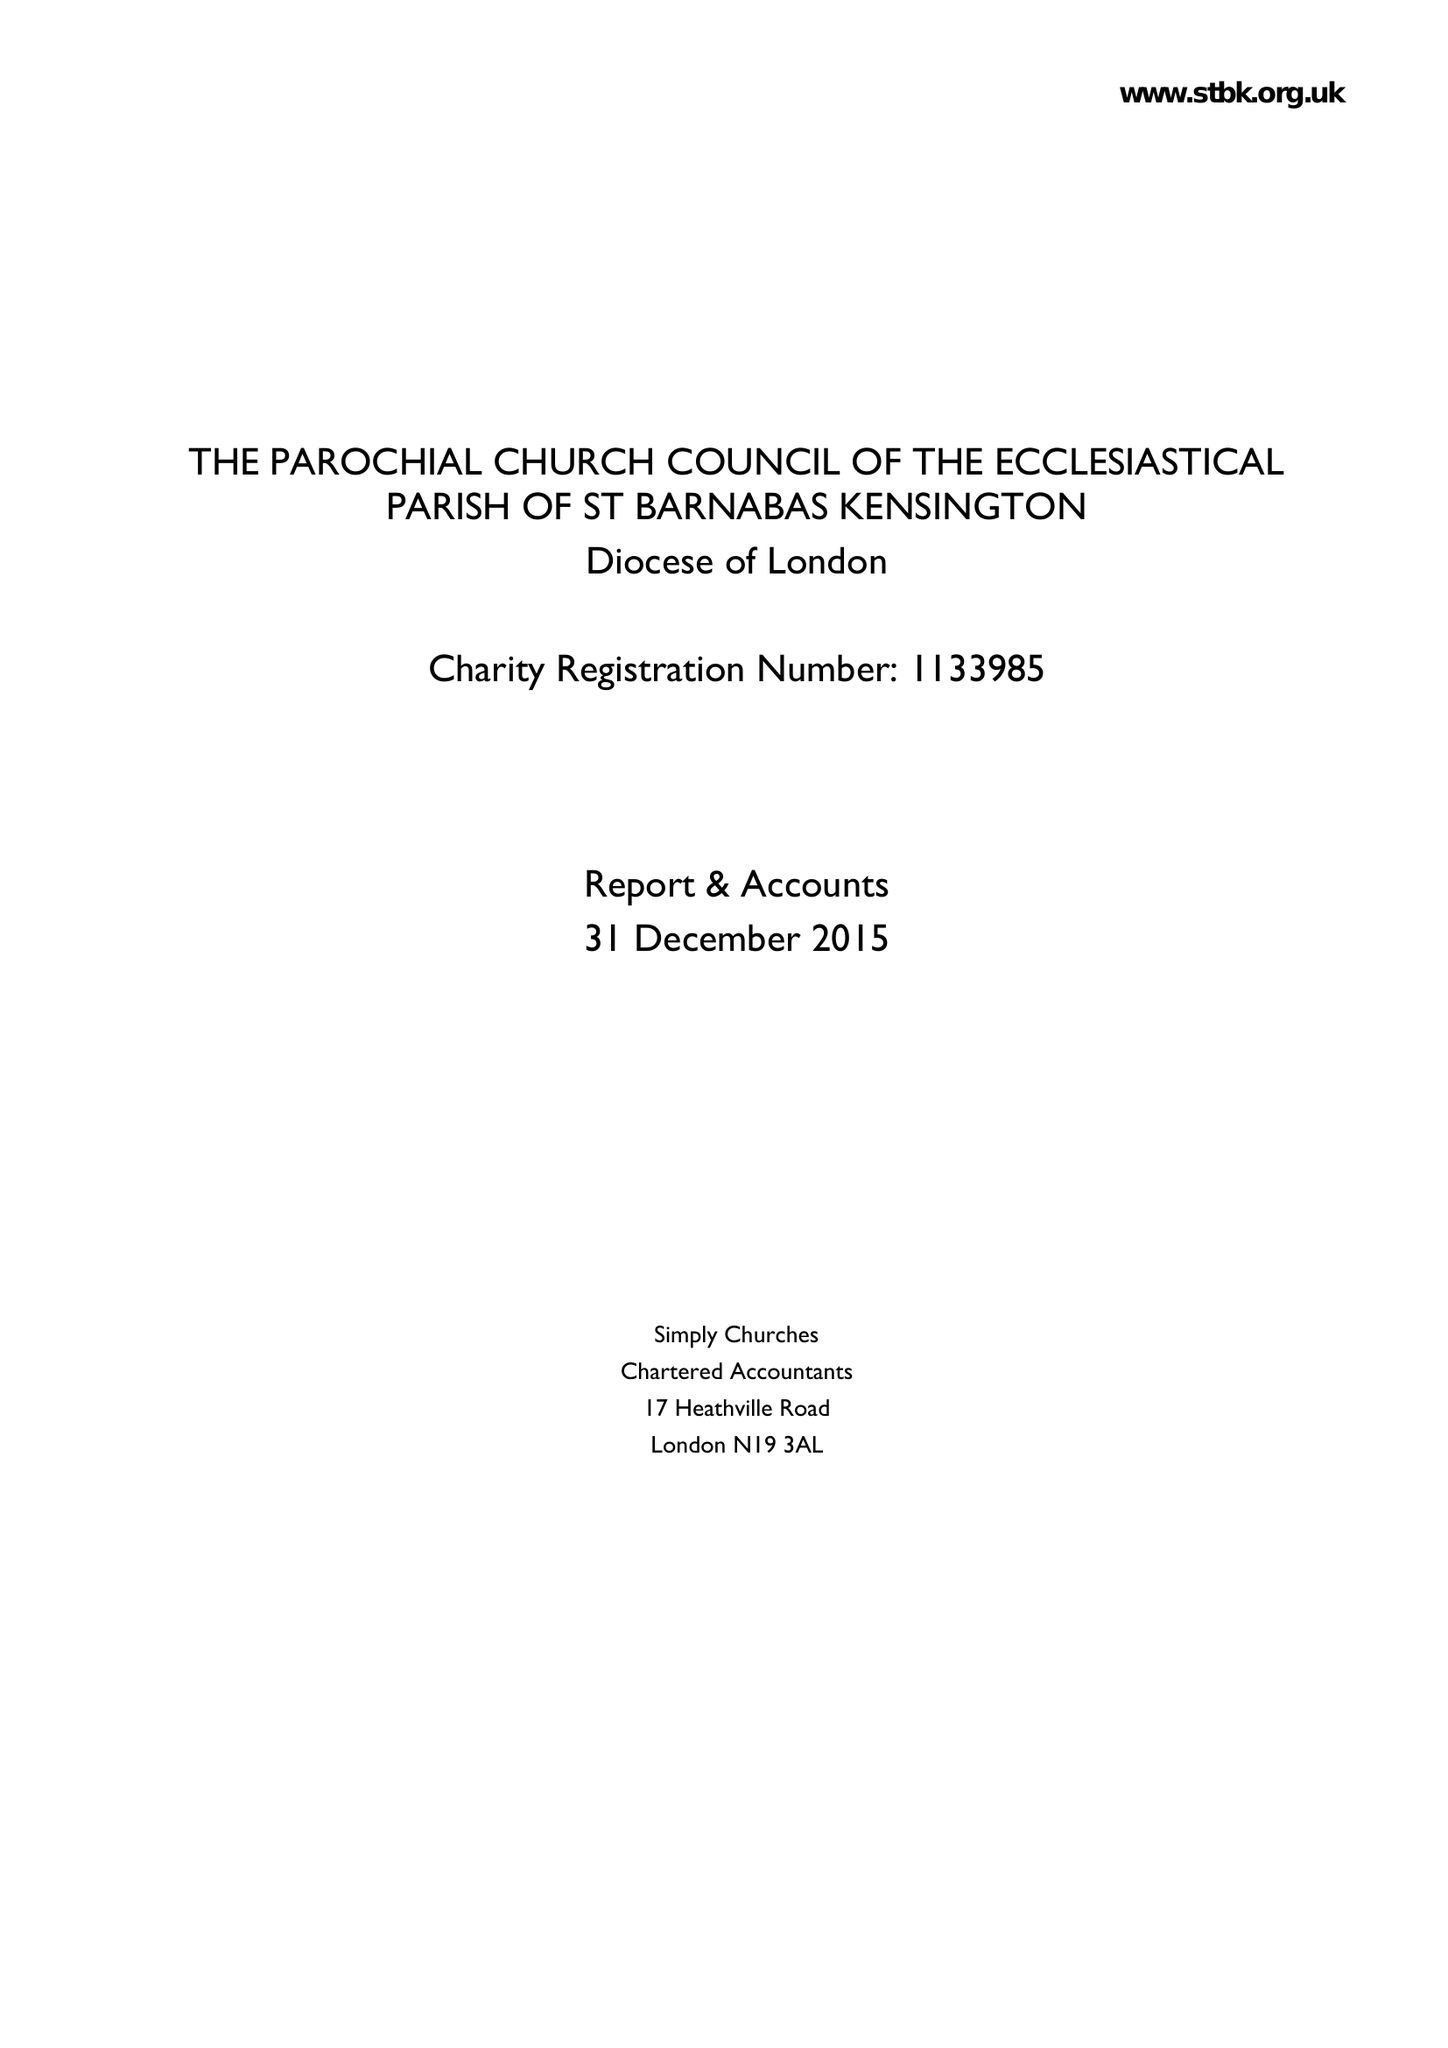What is the value for the spending_annually_in_british_pounds?
Answer the question using a single word or phrase. 492652.00 